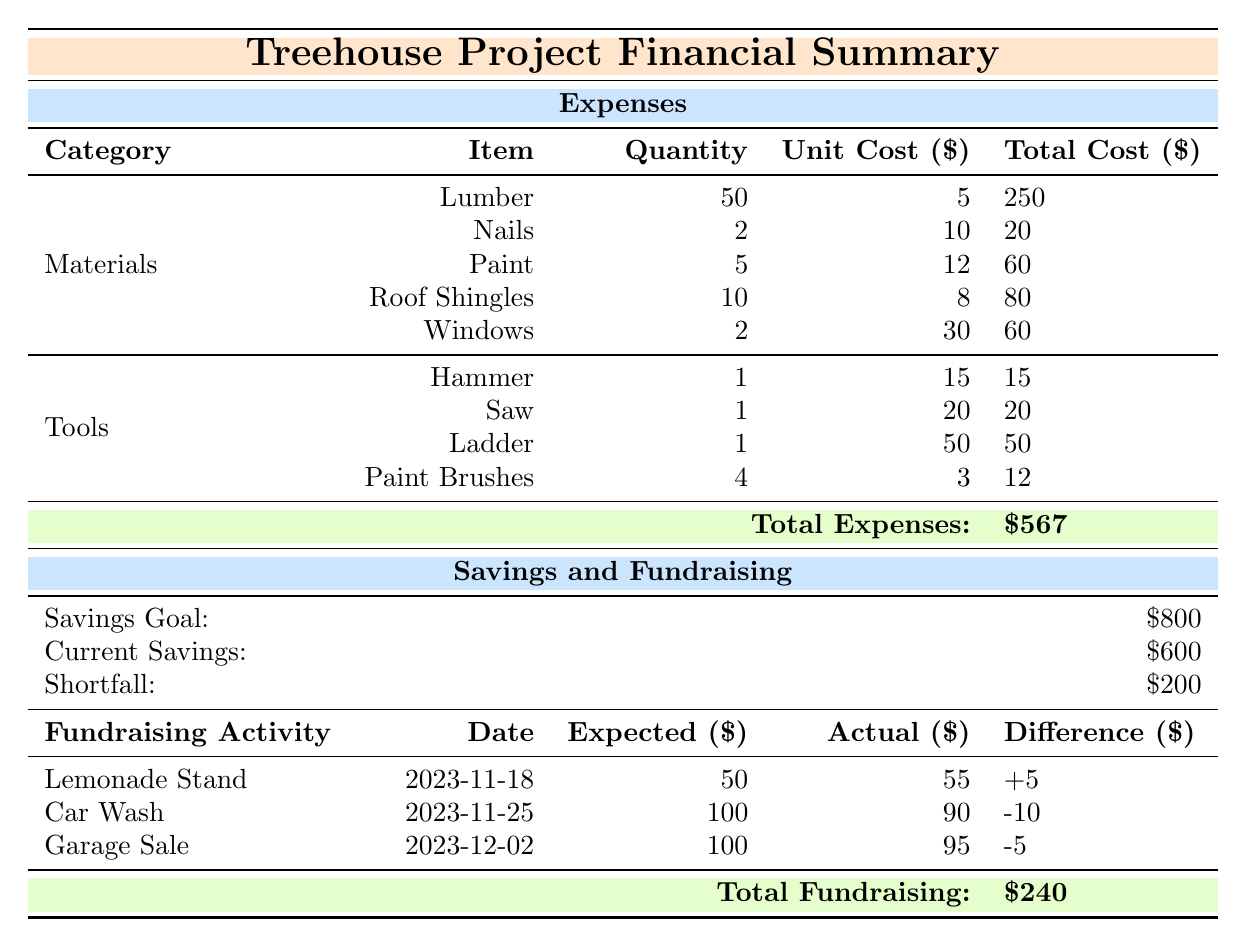What is the total cost for materials? To find the total cost for materials, add the total costs of each item under the Materials category: Lumber ($250) + Nails ($20) + Paint ($60) + Roof Shingles ($80) + Windows ($60) which equals $250 + $20 + $60 + $80 + $60 = $470.
Answer: 470 What is the total cost of tools? To calculate the total cost of tools, sum the total costs of each tool item: Hammer ($15) + Saw ($20) + Ladder ($50) + Paint Brushes ($12) equals $15 + $20 + $50 + $12 = $97.
Answer: 97 Is the current savings greater than the shortfall? The current savings is $600, while the shortfall is $200. Since $600 is greater than $200, the statement is true.
Answer: Yes What was the actual revenue from the Car Wash? The actual revenue from the Car Wash fundraising activity is listed in the table as $90.
Answer: 90 What is the difference between expected and actual revenue from the Lemonade Stand? The expected revenue from the Lemonade Stand is $50 and the actual revenue is $55. The difference is calculated as Actual ($55) - Expected ($50) = $5.
Answer: 5 What is the total cost of the Treehouse Project? To find the total cost of the Treehouse Project, add the total expenses ($567) and subtract the total funds raised from fundraising activities ($240) from the savings goal ($800). The calculation is: Total Cost = Total Expenses + Shortfall, which results in $567 + $200 = $767.
Answer: 767 How much more is needed to reach the savings goal? The savings goal is $800, and the current savings is $600. Therefore, the amount needed is the difference: $800 - $600 = $200.
Answer: 200 Was the actual revenue from the Garage Sale less than the expected revenue? The expected revenue for the Garage Sale was $100, and the actual revenue was $95. Since $95 is less than $100, the statement is true.
Answer: Yes What is the total revenue generated from all fundraising activities? To find the total revenue generated, add the actual revenue from all activities: Lemonade Stand ($55) + Car Wash ($90) + Garage Sale ($95) equals $55 + $90 + $95 = $240.
Answer: 240 